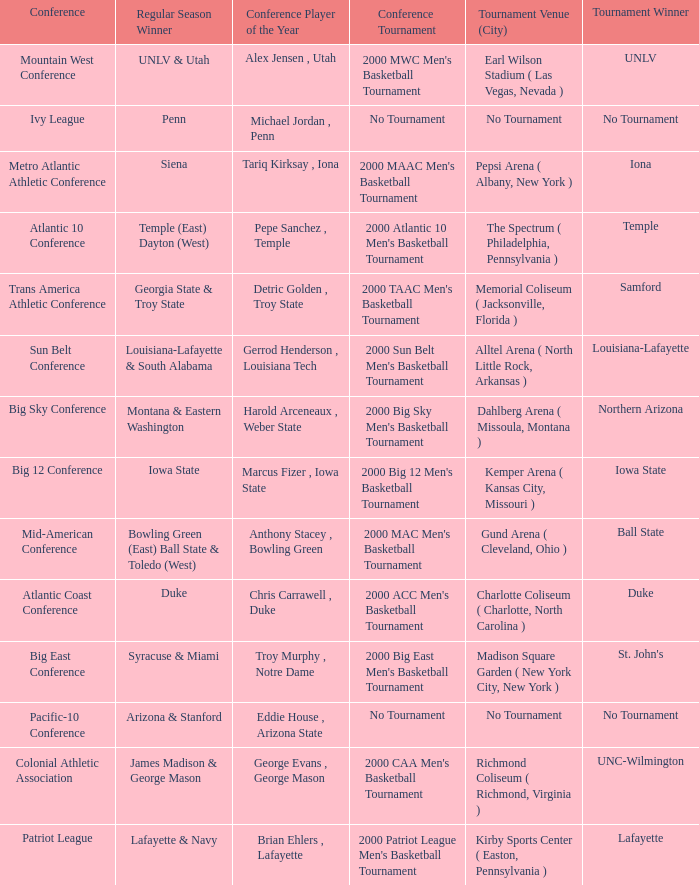Who is the conference Player of the Year in the conference where Lafayette won the tournament? Brian Ehlers , Lafayette. 